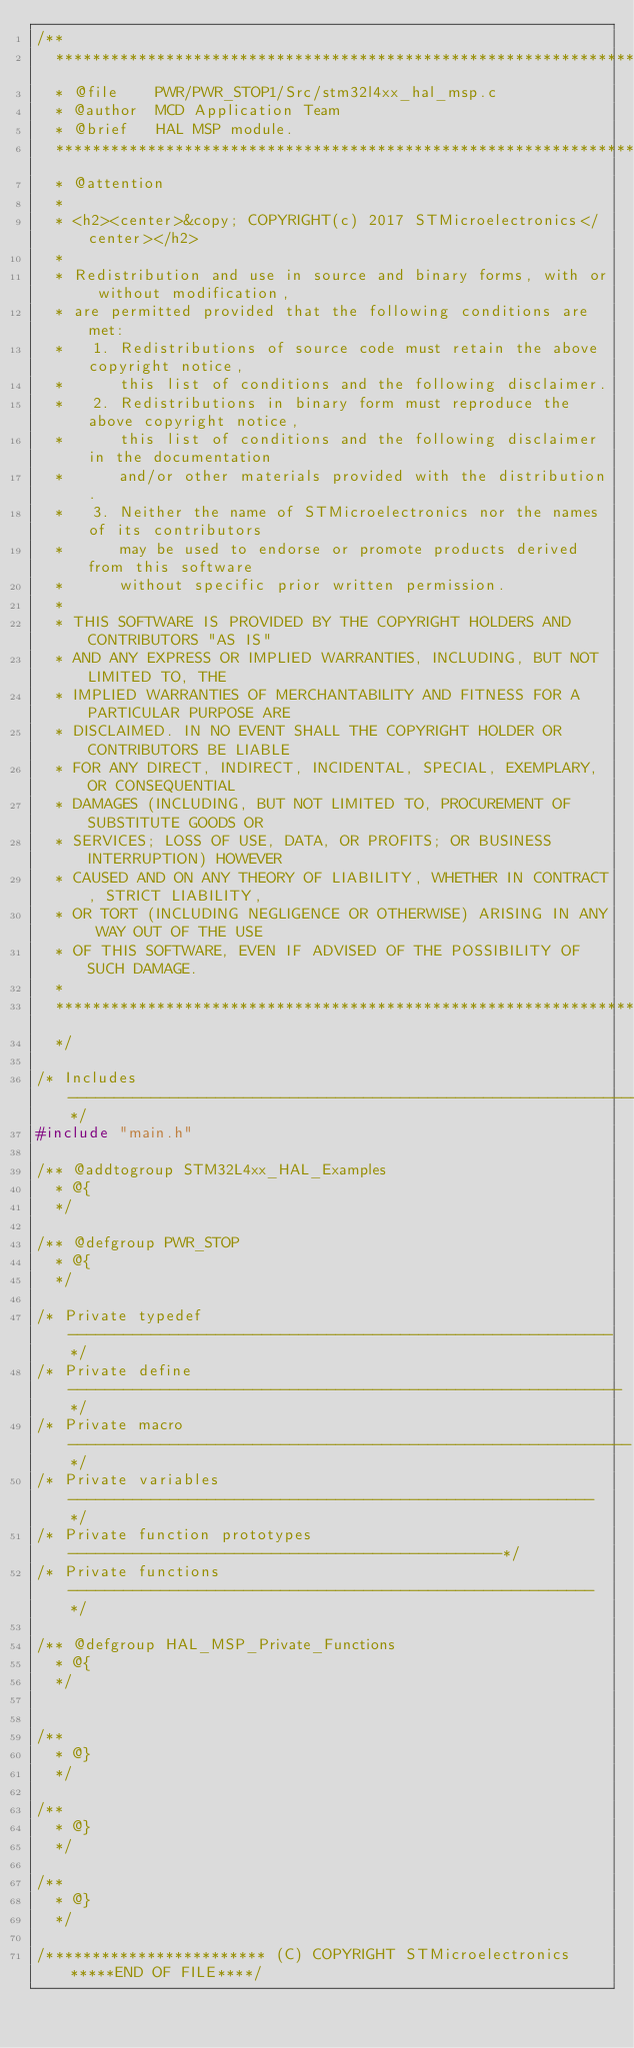<code> <loc_0><loc_0><loc_500><loc_500><_C_>/**
  ******************************************************************************
  * @file    PWR/PWR_STOP1/Src/stm32l4xx_hal_msp.c
  * @author  MCD Application Team
  * @brief   HAL MSP module.
  ******************************************************************************
  * @attention
  *
  * <h2><center>&copy; COPYRIGHT(c) 2017 STMicroelectronics</center></h2>
  *
  * Redistribution and use in source and binary forms, with or without modification,
  * are permitted provided that the following conditions are met:
  *   1. Redistributions of source code must retain the above copyright notice,
  *      this list of conditions and the following disclaimer.
  *   2. Redistributions in binary form must reproduce the above copyright notice,
  *      this list of conditions and the following disclaimer in the documentation
  *      and/or other materials provided with the distribution.
  *   3. Neither the name of STMicroelectronics nor the names of its contributors
  *      may be used to endorse or promote products derived from this software
  *      without specific prior written permission.
  *
  * THIS SOFTWARE IS PROVIDED BY THE COPYRIGHT HOLDERS AND CONTRIBUTORS "AS IS"
  * AND ANY EXPRESS OR IMPLIED WARRANTIES, INCLUDING, BUT NOT LIMITED TO, THE
  * IMPLIED WARRANTIES OF MERCHANTABILITY AND FITNESS FOR A PARTICULAR PURPOSE ARE
  * DISCLAIMED. IN NO EVENT SHALL THE COPYRIGHT HOLDER OR CONTRIBUTORS BE LIABLE
  * FOR ANY DIRECT, INDIRECT, INCIDENTAL, SPECIAL, EXEMPLARY, OR CONSEQUENTIAL
  * DAMAGES (INCLUDING, BUT NOT LIMITED TO, PROCUREMENT OF SUBSTITUTE GOODS OR
  * SERVICES; LOSS OF USE, DATA, OR PROFITS; OR BUSINESS INTERRUPTION) HOWEVER
  * CAUSED AND ON ANY THEORY OF LIABILITY, WHETHER IN CONTRACT, STRICT LIABILITY,
  * OR TORT (INCLUDING NEGLIGENCE OR OTHERWISE) ARISING IN ANY WAY OUT OF THE USE
  * OF THIS SOFTWARE, EVEN IF ADVISED OF THE POSSIBILITY OF SUCH DAMAGE.
  *
  ******************************************************************************
  */

/* Includes ------------------------------------------------------------------*/
#include "main.h"

/** @addtogroup STM32L4xx_HAL_Examples
  * @{
  */

/** @defgroup PWR_STOP
  * @{
  */

/* Private typedef -----------------------------------------------------------*/
/* Private define ------------------------------------------------------------*/
/* Private macro -------------------------------------------------------------*/
/* Private variables ---------------------------------------------------------*/
/* Private function prototypes -----------------------------------------------*/
/* Private functions ---------------------------------------------------------*/

/** @defgroup HAL_MSP_Private_Functions
  * @{
  */


/**
  * @}
  */

/**
  * @}
  */

/**
  * @}
  */

/************************ (C) COPYRIGHT STMicroelectronics *****END OF FILE****/
</code> 